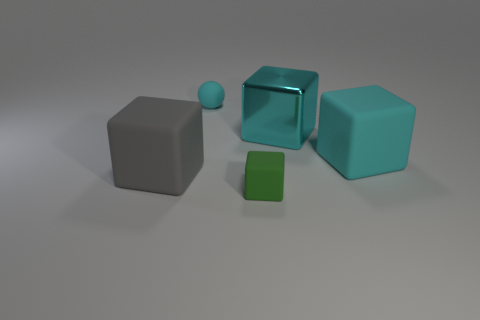What is the material of the big cyan thing in front of the large cyan block behind the big cyan matte block right of the cyan sphere?
Provide a succinct answer. Rubber. Do the small green matte object and the large cyan rubber thing have the same shape?
Give a very brief answer. Yes. What number of shiny objects are either cyan cubes or tiny green objects?
Keep it short and to the point. 1. What number of large brown shiny blocks are there?
Provide a succinct answer. 0. There is a ball that is the same size as the green cube; what color is it?
Offer a terse response. Cyan. Is the size of the gray cube the same as the cyan sphere?
Provide a succinct answer. No. There is a metallic thing that is the same color as the tiny matte sphere; what is its shape?
Ensure brevity in your answer.  Cube. Do the cyan rubber cube and the cyan rubber thing that is left of the small green thing have the same size?
Your answer should be compact. No. There is a rubber cube that is behind the tiny green matte cube and to the right of the large gray rubber object; what is its color?
Your answer should be very brief. Cyan. Is the number of cyan blocks that are in front of the big metal object greater than the number of tiny cyan matte objects that are to the right of the small cyan rubber ball?
Make the answer very short. Yes. 